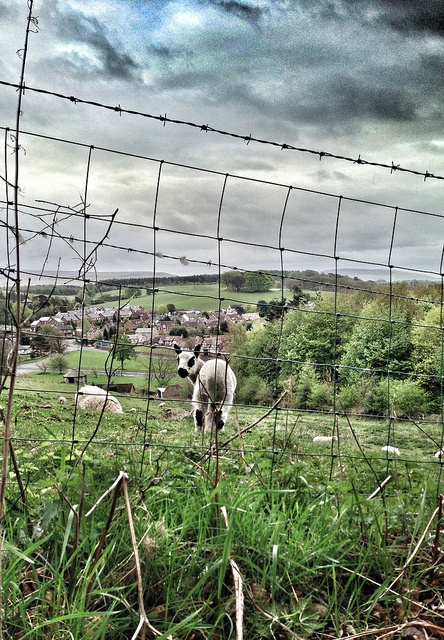Describe the objects in this image and their specific colors. I can see sheep in lightblue, lightgray, black, gray, and darkgray tones and sheep in lightblue, ivory, tan, and gray tones in this image. 